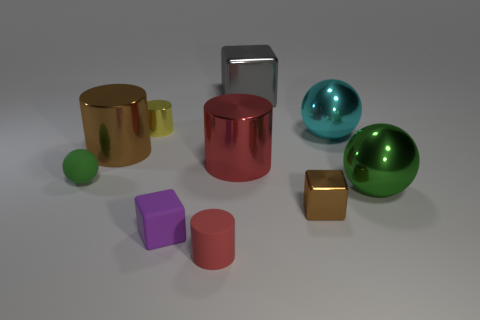Can you describe the lighting and shadows in the scene? The lighting appears to be diffuse, casting soft-edged shadows to the right of the objects, indicating that the light source is to the left of the scene. The overall illumination is even, giving the objects a gentle contrast against the light gray background. 